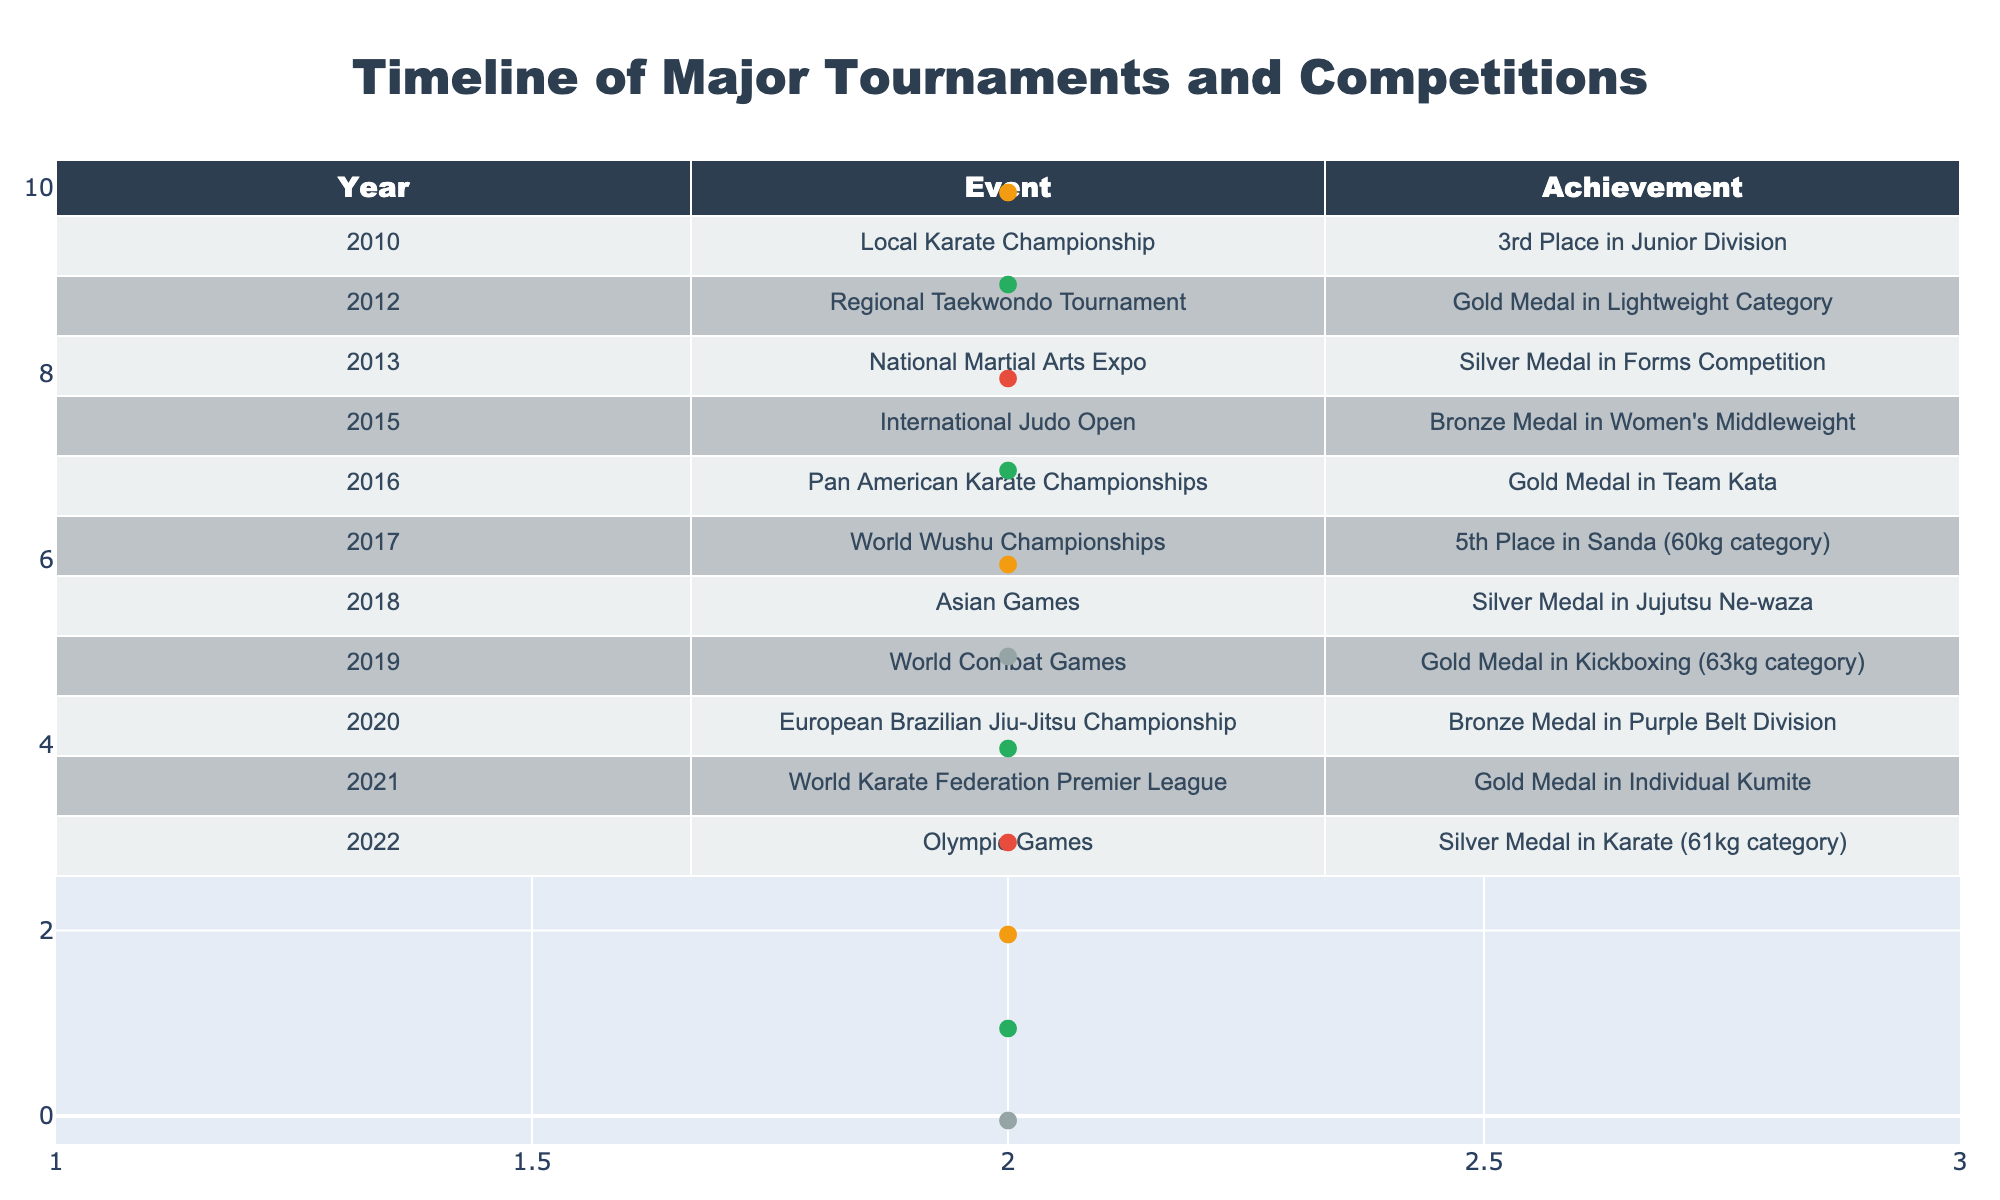What year did she achieve her first gold medal? In the table, the first instance of a gold medal is in 2012 at the Regional Taekwondo Tournament. Thus, the year is 2012.
Answer: 2012 How many medals did she win in the year 2019? In 2019, she participated in the World Combat Games and won a gold medal. Therefore, she won 1 medal that year.
Answer: 1 What is the total number of events she participated in between 2010 and 2020? Counting the events from 2010 to 2020, there are 11 events listed in the table. Thus, the total is 11.
Answer: 11 Did she participate in any tournament that resulted in a bronze medal in both 2015 and 2020? Yes, she won a bronze medal in the International Judo Open in 2015 and again in the European Brazilian Jiu-Jitsu Championship in 2020.
Answer: Yes What was her average placement in the events listed from 2010 to 2022? The placements that can be quantified are as follows: 3rd, 1st, 2nd, 3rd, 1st, 5th, 2nd, 1st, 3rd, 1st, and 2nd. Converting these to numerical values: 3, 1, 2, 3, 1, 5, 2, 1, 3, 1, 2 gives a total of 2.27 when averaged (sum is 25, and there are 11 events).
Answer: 2.27 Which event had the highest medal achievement? The highest achievement is a gold medal, which she earned on multiple occasions: 2012, 2016, 2019, and 2021. The event with the latest date is the World Karate Federation Premier League in 2021.
Answer: 2021 How many events resulted in a silver medal? In the data, she won silver medals at the National Martial Arts Expo in 2013, Asian Games in 2018, and Olympic Games in 2022. Thus, there are 3 silver medals.
Answer: 3 In which category did she achieve a silver medal in 2022? According to the table, she won a silver medal in Karate in the 61kg category at the Olympic Games in 2022.
Answer: 61kg category 